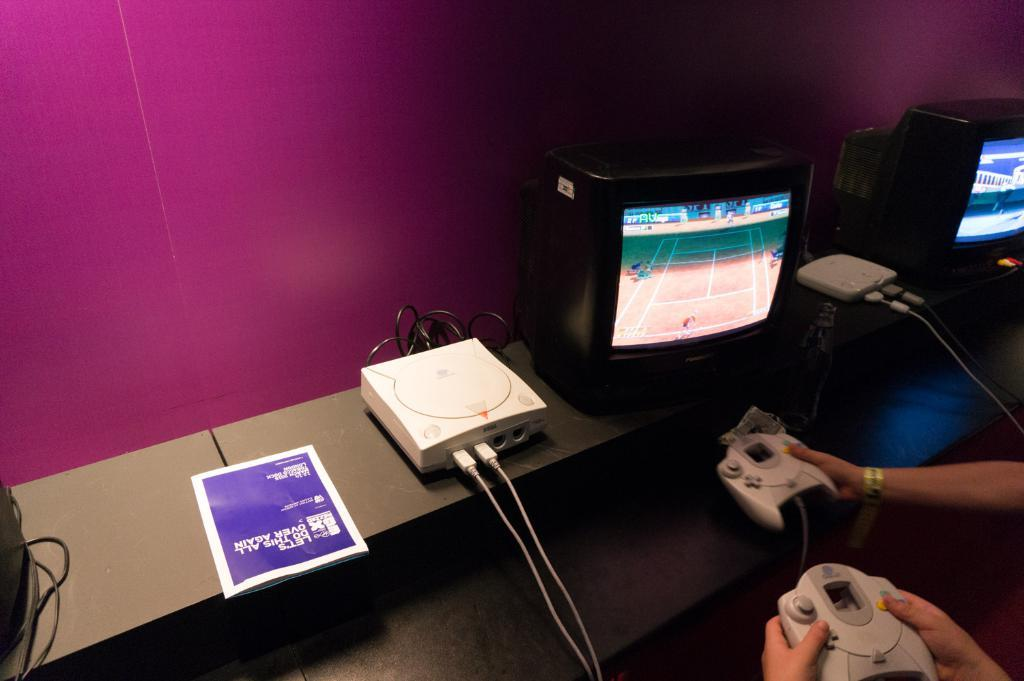<image>
Give a short and clear explanation of the subsequent image. A magazine that says "Let's do this all over again" is next to people playing video games. 